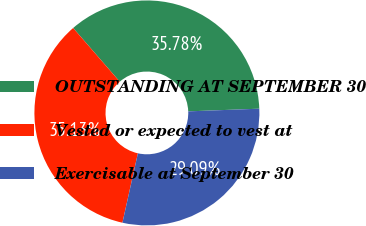Convert chart. <chart><loc_0><loc_0><loc_500><loc_500><pie_chart><fcel>OUTSTANDING AT SEPTEMBER 30<fcel>Vested or expected to vest at<fcel>Exercisable at September 30<nl><fcel>35.78%<fcel>35.13%<fcel>29.09%<nl></chart> 